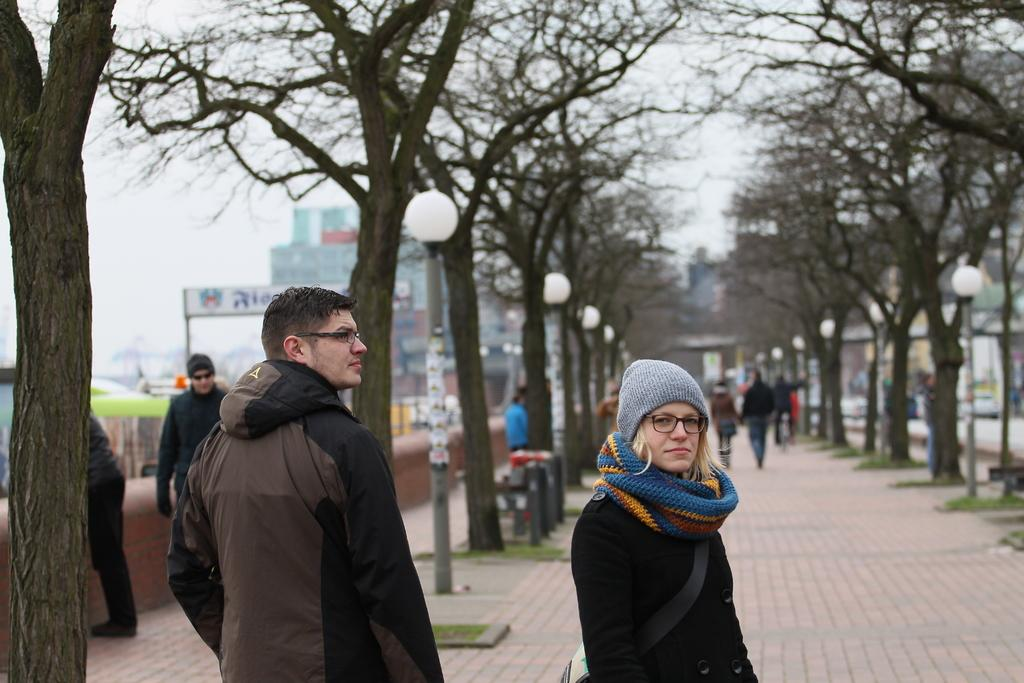What are the people in the image doing? The people in the image are standing on the floor. What type of natural elements can be seen in the image? There are trees in the image. What type of man-made structures are present in the image? There are buildings in the image. What might be used for providing information or directions in the image? Information boards are present in the image. What type of vertical structures can be seen in the image? Poles are visible in the image. What type of artificial light source is visible in the image? Electric lights are in the image. What part of the natural environment is visible in the image? The sky is visible in the image. Reasoning: Let's present in the image, so it is not possible to determine what, if any, hymns might be heard. Absurd Question/Answer: What type of wood is being used to build the cars in the image? There are no cars present in the image, so it is not possible to determine what type of wood might be used for building them. What type of milk is being served in the image? There is no milk present in the image. What type of wood can be seen in the image? There is no wood present in the image. 